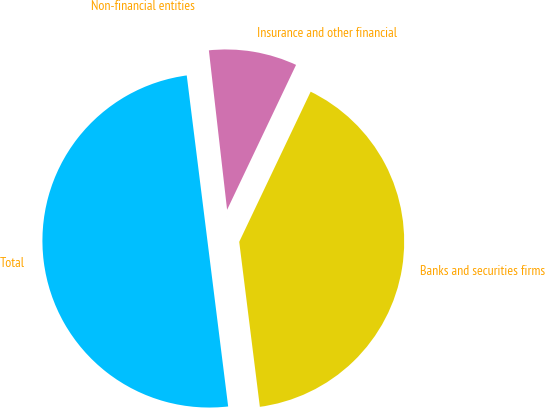<chart> <loc_0><loc_0><loc_500><loc_500><pie_chart><fcel>Banks and securities firms<fcel>Insurance and other financial<fcel>Non-financial entities<fcel>Total<nl><fcel>40.95%<fcel>8.88%<fcel>0.17%<fcel>50.0%<nl></chart> 